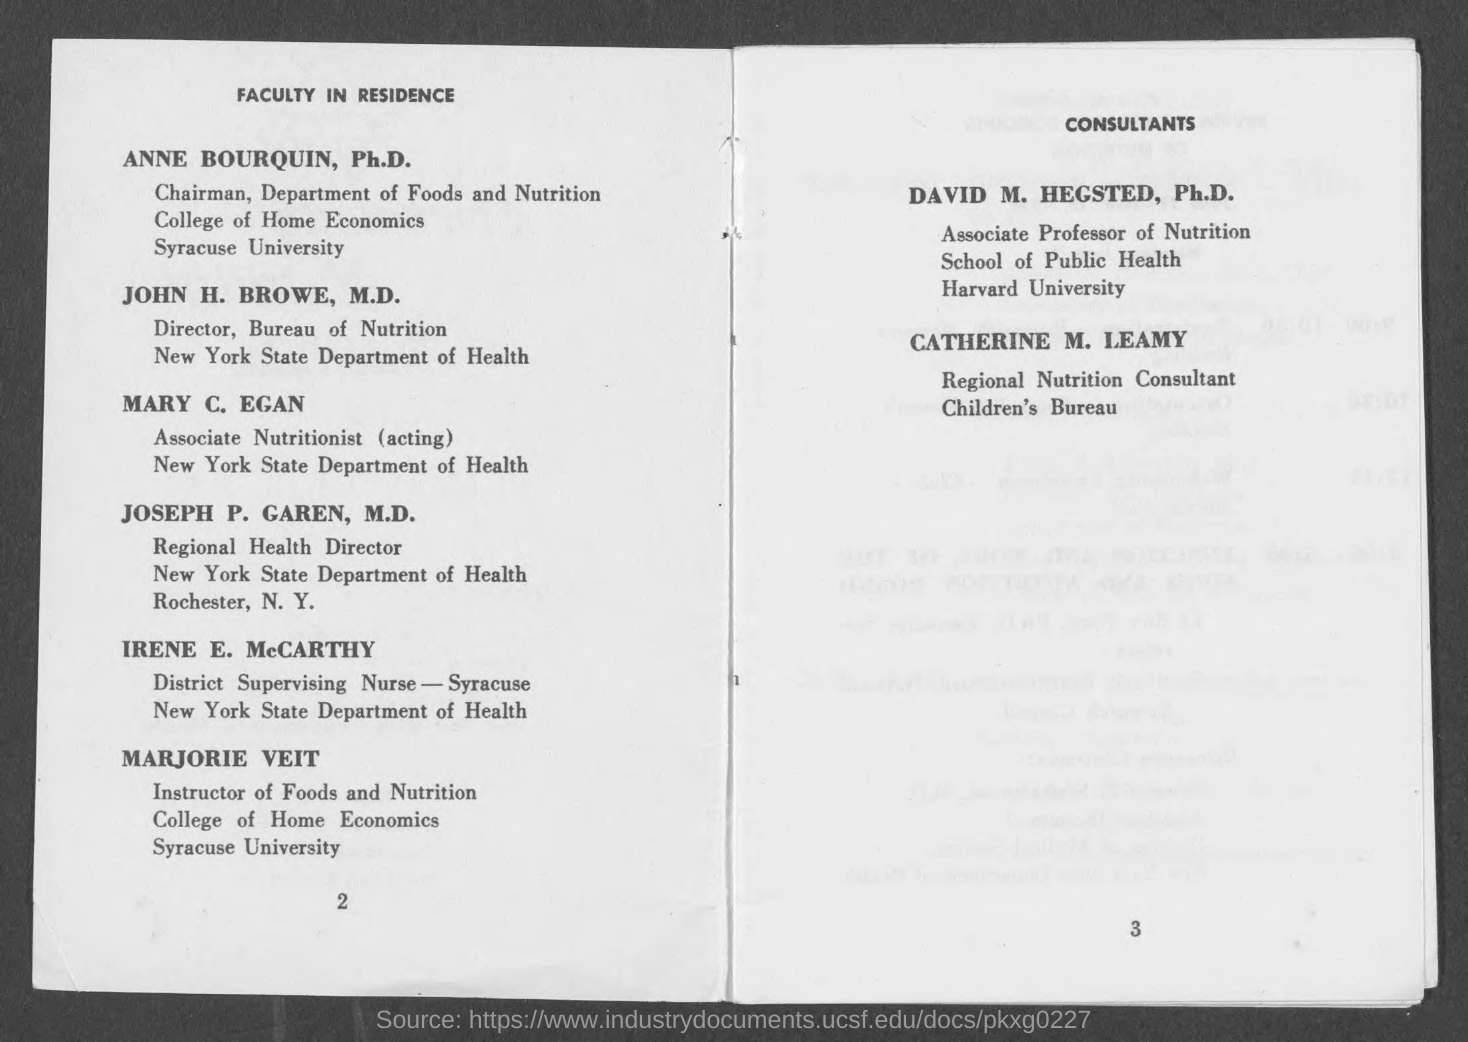Who is ANNE BOURQUIN, Ph.D.?
Give a very brief answer. Chairman, Department of Foods and Nutrition. Who is the Director, Bureau of Nutrition?
Your answer should be very brief. John H. Browe, M.D. 